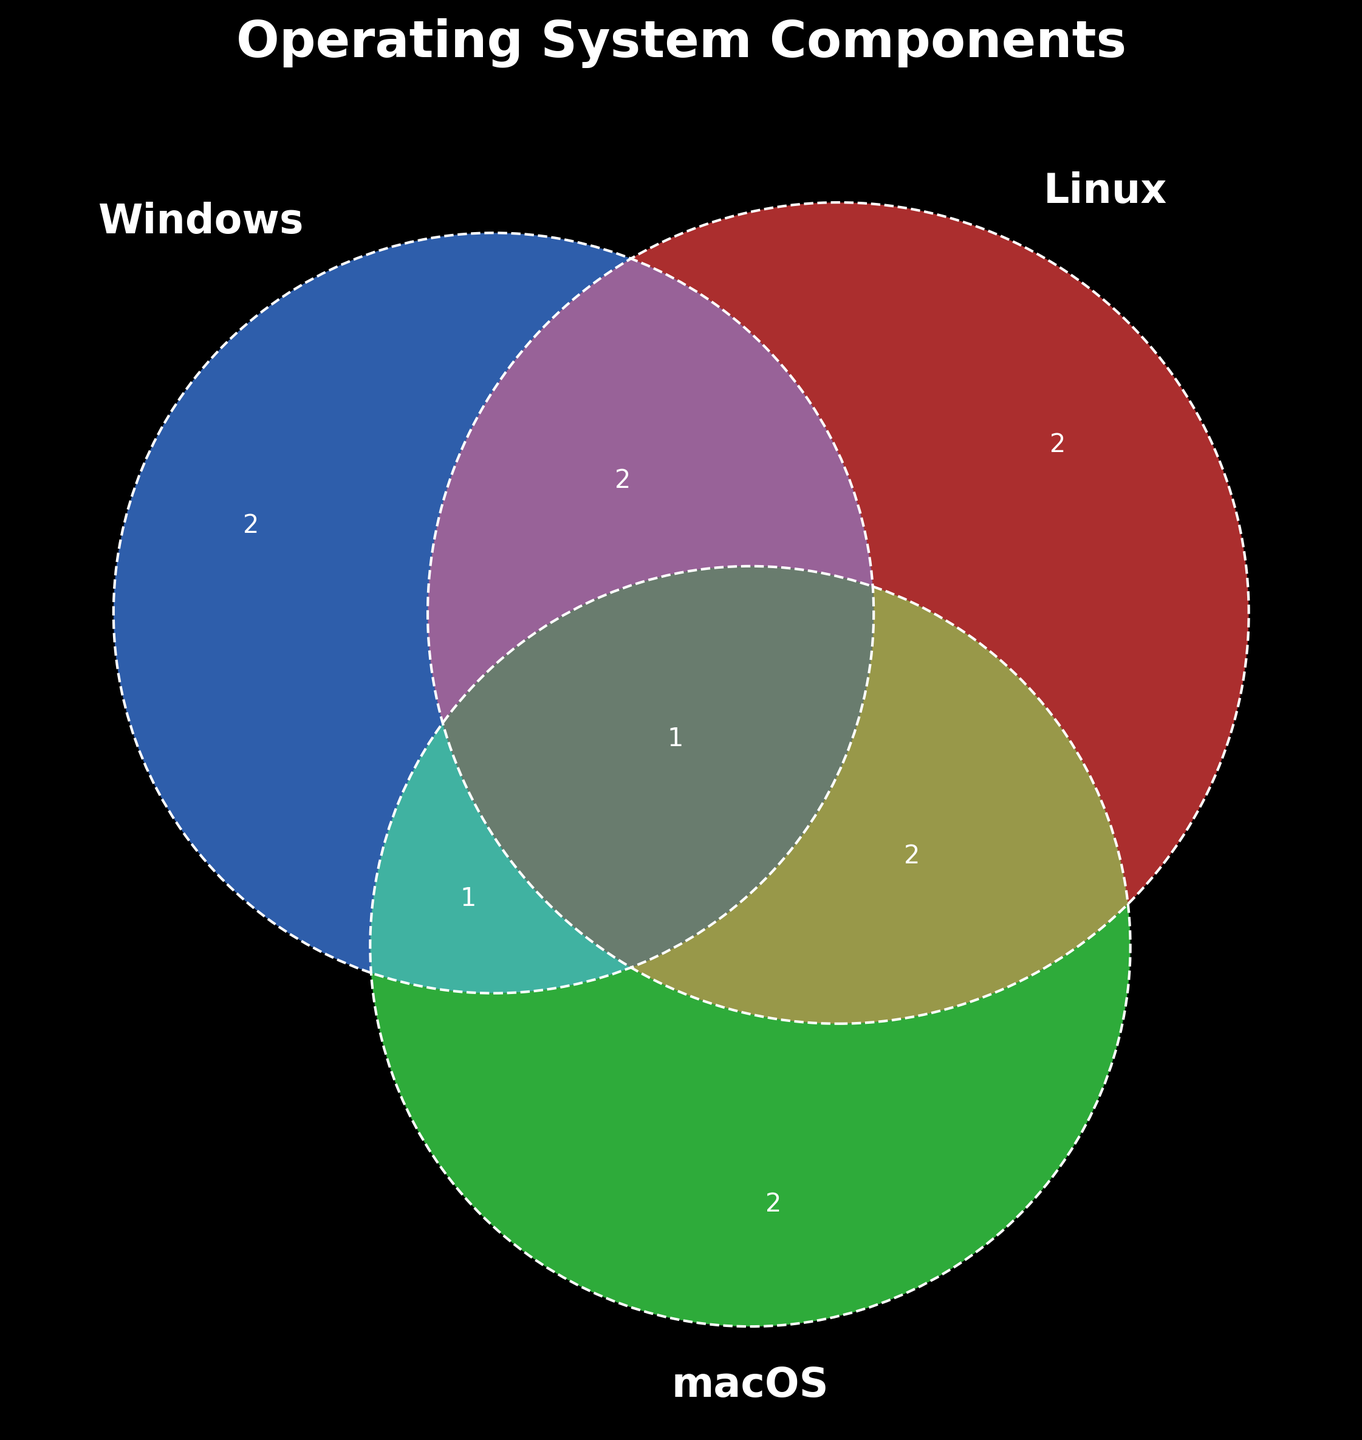What is the title of the Venn Diagram? The title is located at the top of the diagram.
Answer: Operating System Components Which operating systems have "Kernel" as a common component? Look for the part of the diagram where "Kernel" falls in the intersection of the sets.
Answer: Windows, Linux, macOS Which operating system exclusively has "DirectX" as a component? Identify the components that are unique to each operating system and find "DirectX".
Answer: Windows What components are shared between Windows and Linux, but not macOS? Examine the intersection between Windows and Linux that excludes macOS.
Answer: File System, Device Drivers Do any components belong to all three operating systems? Find any components that lie in the center where all three sets intersect.
Answer: Kernel Which operating systems are UNIX-based? Check the part of the diagram that contains "UNIX-based".
Answer: Linux, macOS Which operating system has the most unique components in the Venn Diagram? Count the unique components in each section that only pertains to one operating system.
Answer: macOS How many components are common between Linux and macOS? Check the shared area between Linux and macOS and count the components listed.
Answer: 3 What is the component shared between Windows and macOS, but not Linux? Locate the intersecting area between Windows and macOS, excluding Linux.
Answer: Graphical User Interface 